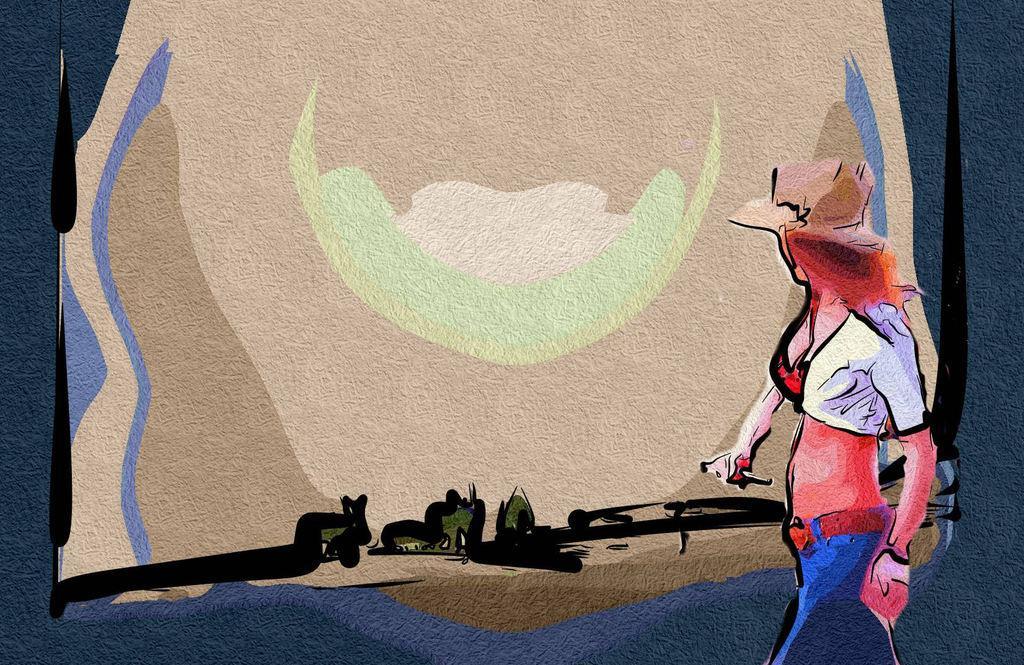Please provide a concise description of this image. This image consists of a painting. On the right side there is a person walking towards the left side. 